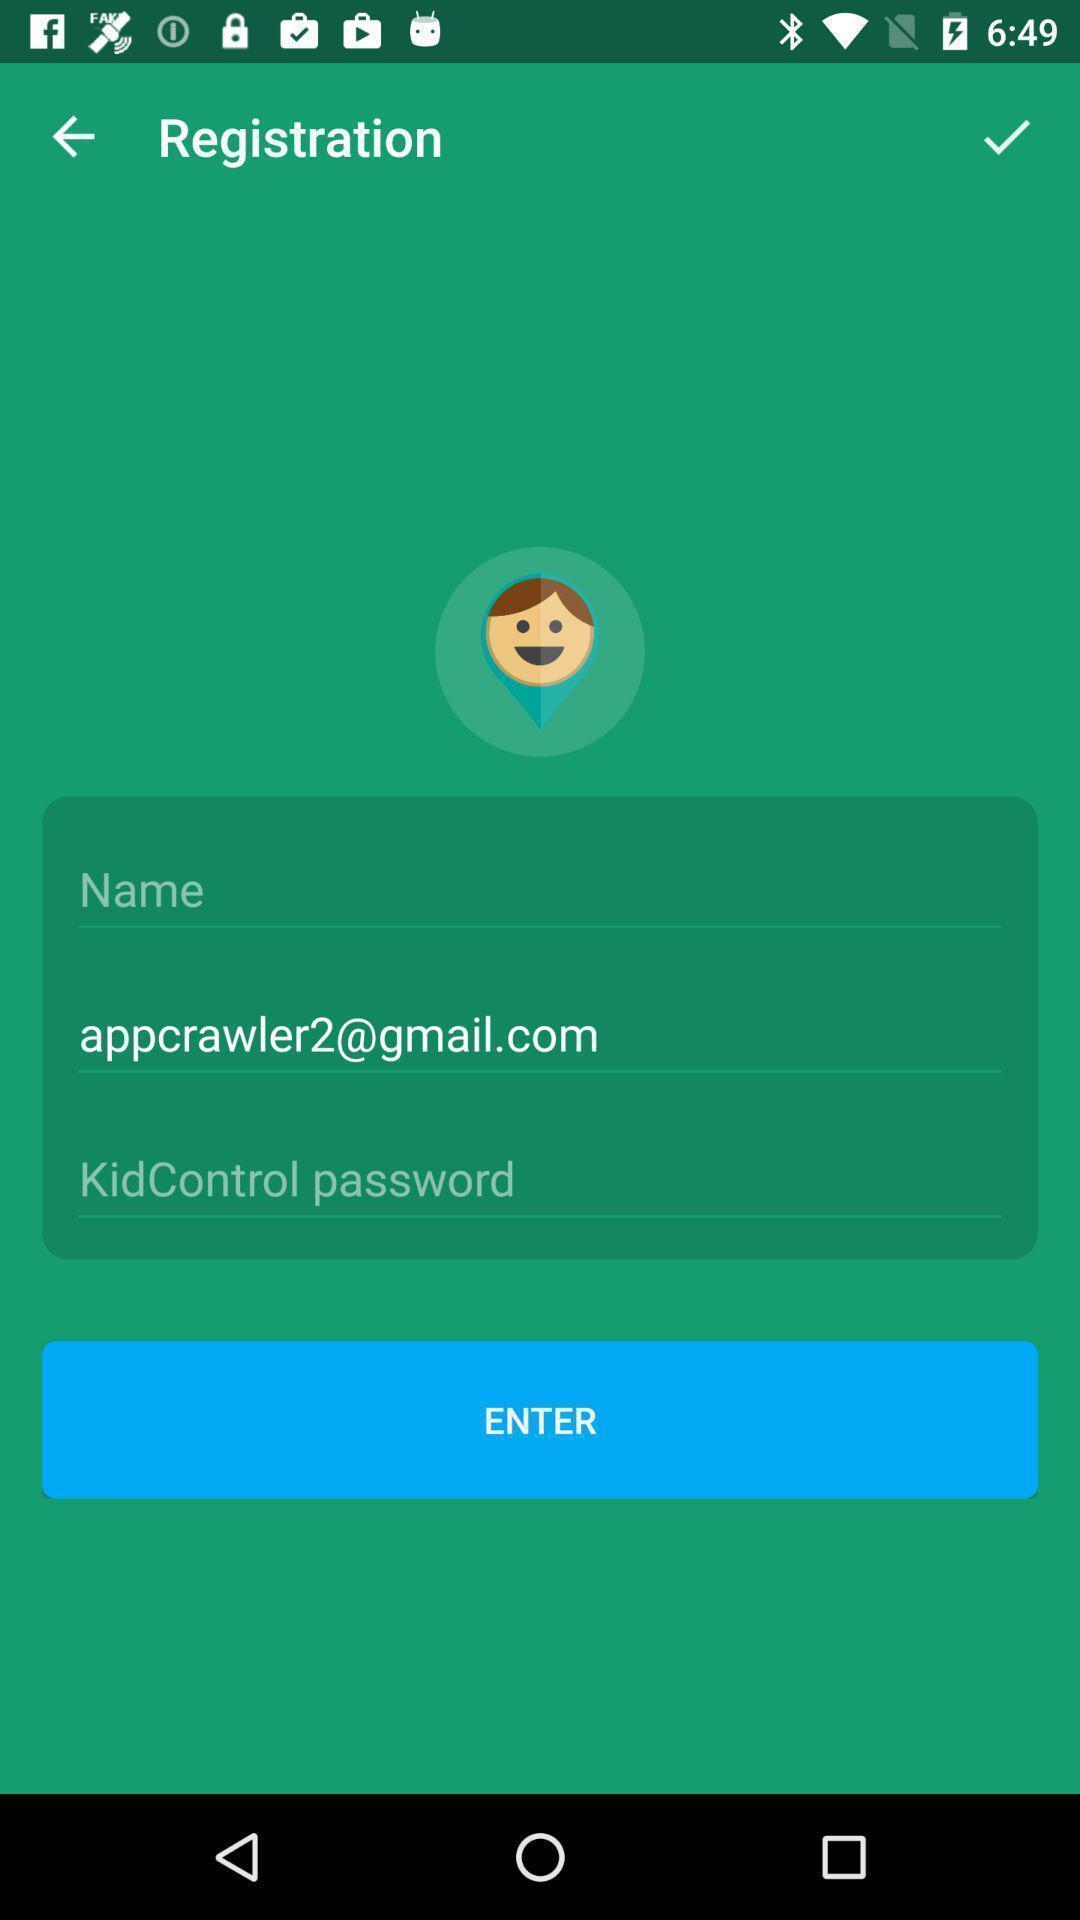Summarize the main components in this picture. Page displaying to enter personal information in app. 